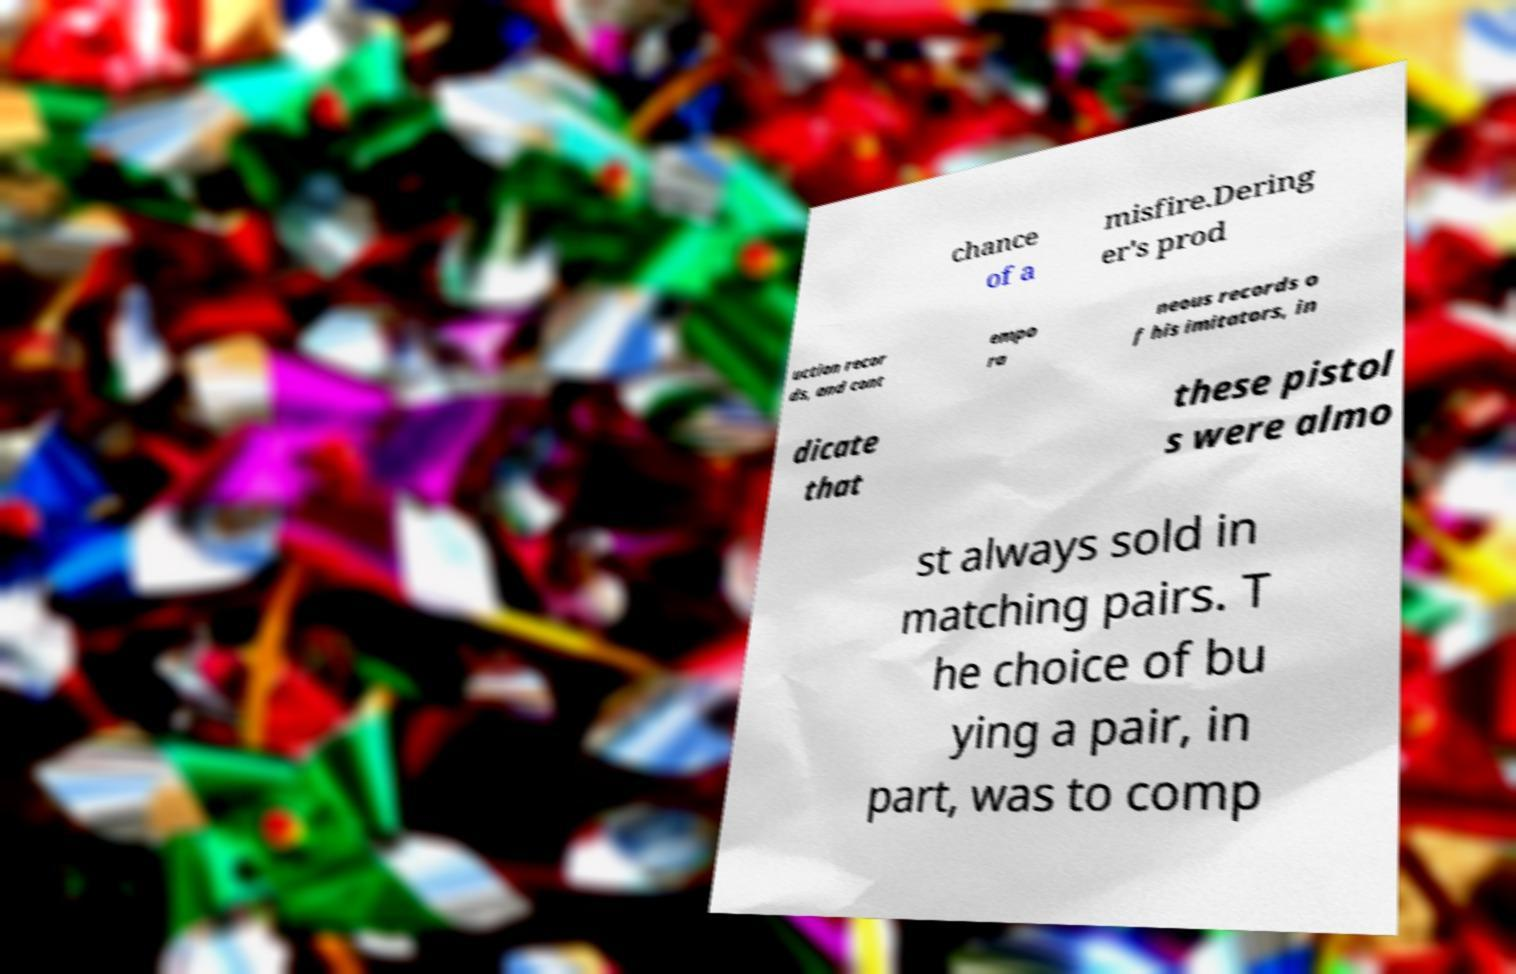I need the written content from this picture converted into text. Can you do that? chance of a misfire.Dering er's prod uction recor ds, and cont empo ra neous records o f his imitators, in dicate that these pistol s were almo st always sold in matching pairs. T he choice of bu ying a pair, in part, was to comp 